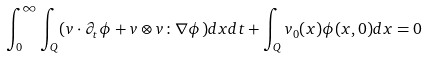Convert formula to latex. <formula><loc_0><loc_0><loc_500><loc_500>\int _ { 0 } ^ { \infty } \int _ { Q } ( v \cdot \partial _ { t } \phi + v \otimes v \colon \nabla \phi ) d x d t + \int _ { Q } v _ { 0 } ( x ) \phi ( x , 0 ) d x = 0</formula> 